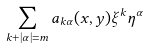<formula> <loc_0><loc_0><loc_500><loc_500>\sum _ { k + | \alpha | = m } a _ { k \alpha } ( x , y ) \xi ^ { k } \eta ^ { \alpha }</formula> 